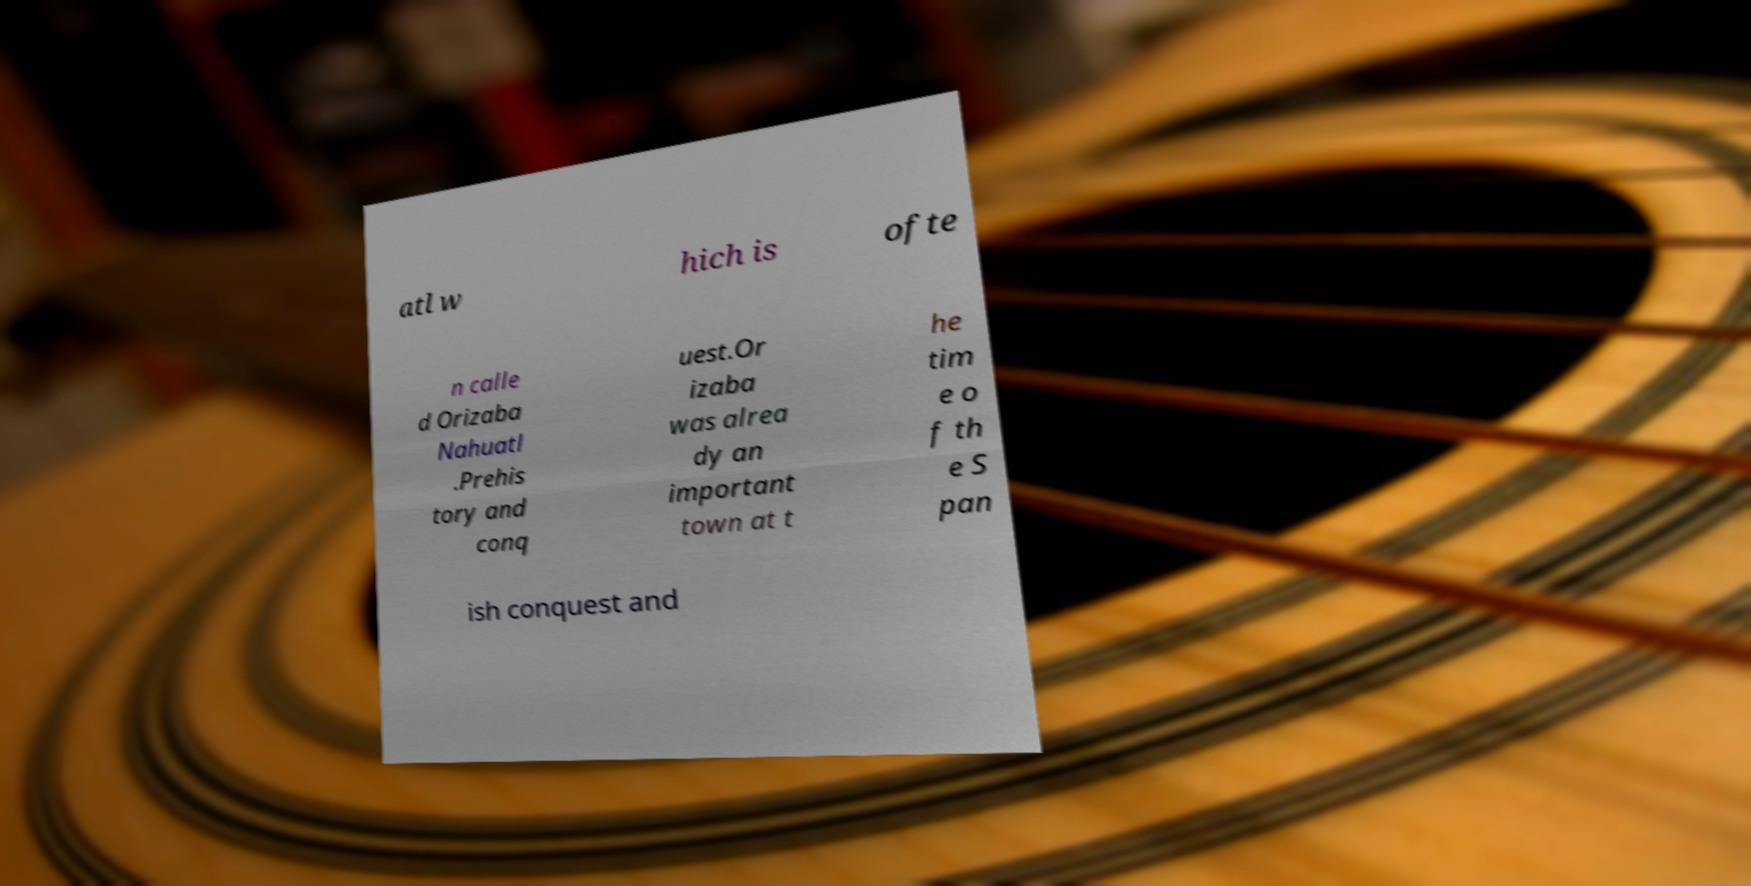I need the written content from this picture converted into text. Can you do that? atl w hich is ofte n calle d Orizaba Nahuatl .Prehis tory and conq uest.Or izaba was alrea dy an important town at t he tim e o f th e S pan ish conquest and 